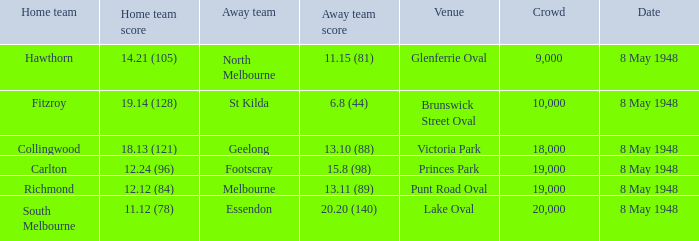How many spectators were at the game when the away team scored 15.8 (98)? 19000.0. 